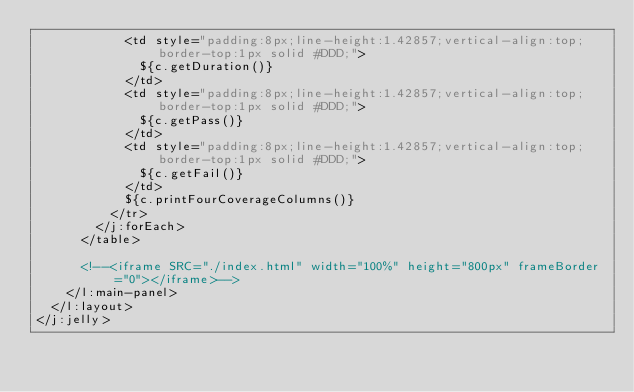Convert code to text. <code><loc_0><loc_0><loc_500><loc_500><_XML_>            <td style="padding:8px;line-height:1.42857;vertical-align:top;border-top:1px solid #DDD;">
              ${c.getDuration()}
            </td>
            <td style="padding:8px;line-height:1.42857;vertical-align:top;border-top:1px solid #DDD;">
              ${c.getPass()}
            </td>
            <td style="padding:8px;line-height:1.42857;vertical-align:top;border-top:1px solid #DDD;">
              ${c.getFail()}
            </td>
            ${c.printFourCoverageColumns()}
          </tr>
        </j:forEach>
      </table>

      <!--<iframe SRC="./index.html" width="100%" height="800px" frameBorder="0"></iframe>-->
    </l:main-panel>
  </l:layout>
</j:jelly>
</code> 